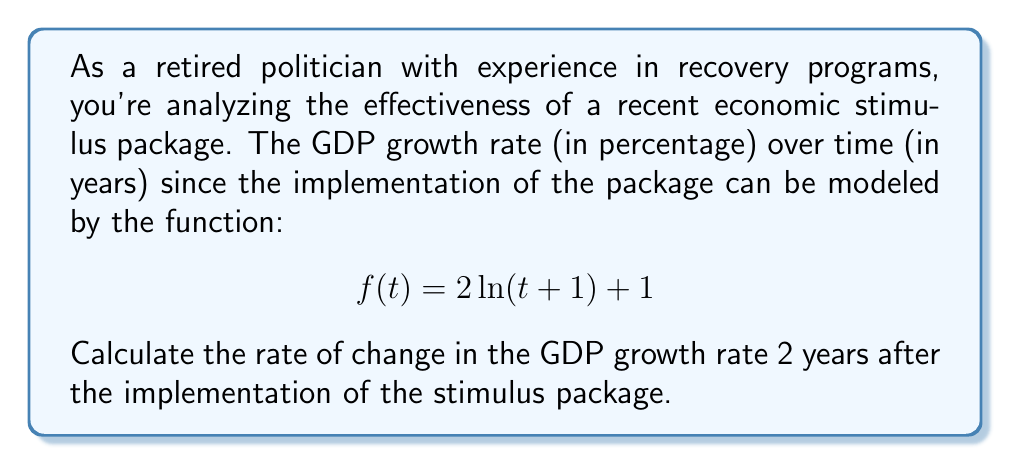Teach me how to tackle this problem. To solve this problem, we need to find the rate of change (slope) of the GDP growth rate function at t = 2 years. This can be done by calculating the derivative of the function and evaluating it at t = 2.

1. First, let's find the derivative of $f(t)$:
   $$f(t) = 2\ln(t+1) + 1$$
   $$f'(t) = \frac{2}{t+1}$$

2. Now, we evaluate $f'(t)$ at t = 2:
   $$f'(2) = \frac{2}{2+1} = \frac{2}{3}$$

3. The rate of change is the value of the derivative at the given point. In this case, it's $\frac{2}{3}$ or approximately 0.6667.

4. Interpretation: This means that 2 years after the implementation of the stimulus package, the GDP growth rate is increasing at a rate of $\frac{2}{3}$ percentage points per year.

This analysis helps in understanding the ongoing impact of the recovery program on the economy's growth rate.
Answer: $\frac{2}{3}$ or approximately 0.6667 percentage points per year 